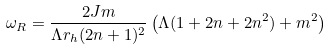<formula> <loc_0><loc_0><loc_500><loc_500>\omega _ { R } = \frac { 2 J m } { \Lambda r _ { h } ( 2 n + 1 ) ^ { 2 } } \left ( \Lambda ( 1 + 2 n + 2 n ^ { 2 } ) + m ^ { 2 } \right )</formula> 